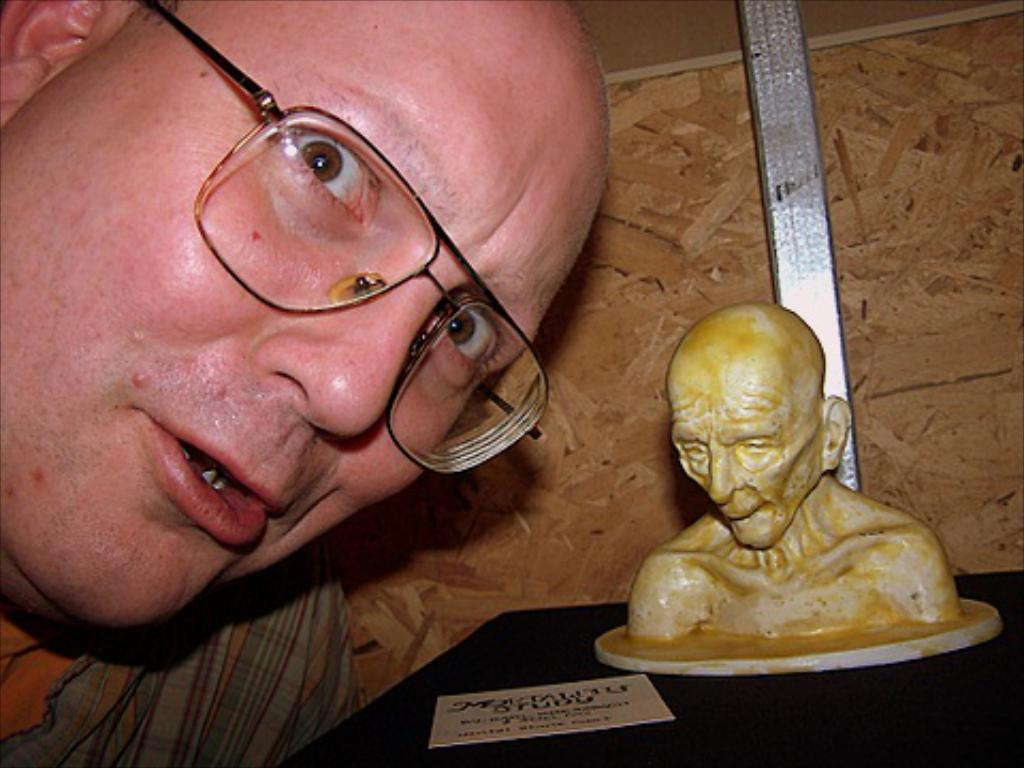What is the main subject of the image? There is a person's face in the image. What can be seen on the person's face? The person is wearing spectacles. What other object is present in the image? There is a statue in the image. What type of wall is visible in the background? The background of the image includes a wooden wall. What is the color of the wooden wall? The wooden wall is brown in color. What type of wound can be seen on the person's face in the image? There is no wound visible on the person's face in the image. What level of hope is the person expressing through their facial expression in the image? The image does not convey any specific level of hope, as it only shows the person's face and spectacles. 